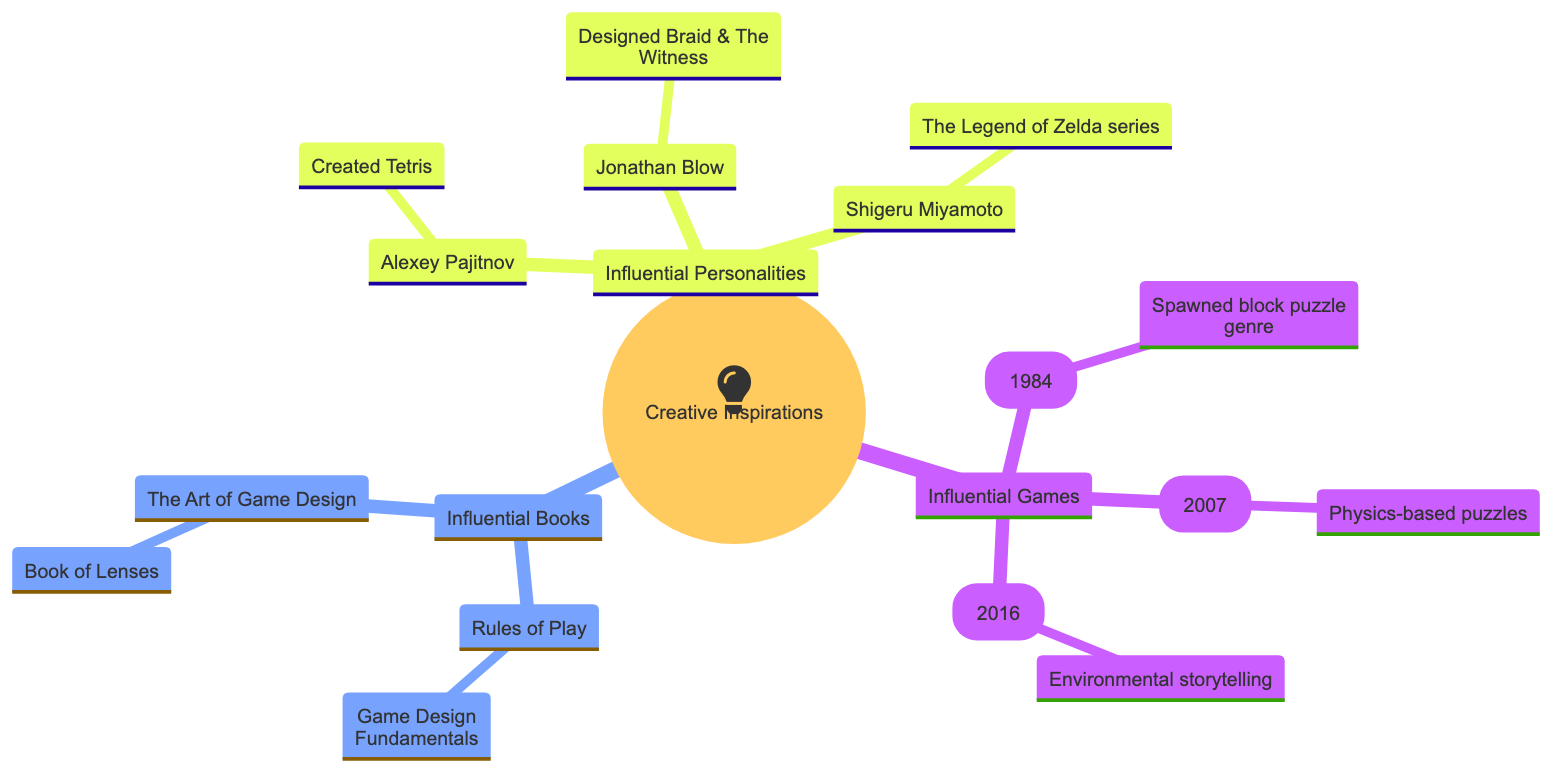What is the root of the family tree? The root node of the family tree is labeled "Creative Inspirations." This is the top-most node from which all other branches derive.
Answer: Creative Inspirations How many influential games are listed? By counting the child nodes under the "Influential Games" branch, there are three games named: Tetris, Portal, and The Witness.
Answer: 3 What year was Portal released? The specific information for Portal is indicated directly under the node, stating that it was released in the year 2007.
Answer: 2007 Who created Tetris? Under the "Influential Personalities" branch, there is a node for Alexey Pajitnov that states he created Tetris.
Answer: Alexey Pajitnov What is the primary influence of The Witness? The influence of The Witness is noted as focusing on "environmental storytelling and complex, layered puzzles," which is directly indicated under its node.
Answer: Environmental storytelling Which book is authored by Jesse Schell? Under the "Influential Books" branch, there is a book titled "The Art of Game Design: A Book of Lenses," and it specifically states that Jesse Schell is the author.
Answer: The Art of Game Design: A Book of Lenses How many influential personalities are mentioned in total? The "Influential Personalities" branch contains three nodes: Alexey Pajitnov, Jonathan Blow, and Shigeru Miyamoto, which totals to three influential personalities.
Answer: 3 What common theme do Tetris and Portal share? Both games are under the "Influential Games" branch and share a theme of innovation in puzzle gameplay mechanics. Tetris introduced block puzzles, while Portal introduced physics-based puzzles.
Answer: Innovation in puzzle gameplay mechanics Which game by Jonathan Blow is noted in this diagram? The diagram specifies that Jonathan Blow designed both Braid and The Witness, with these titles directly listed under his contribution node.
Answer: Braid and The Witness 